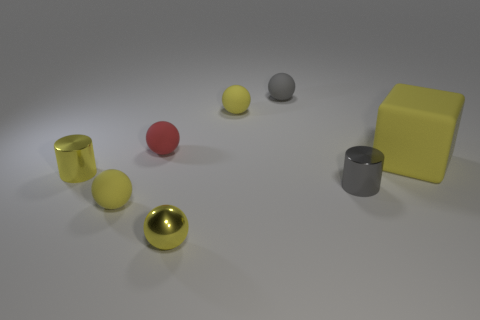How many yellow balls must be subtracted to get 1 yellow balls? 2 Subtract all yellow cubes. How many yellow spheres are left? 3 Subtract all gray balls. How many balls are left? 4 Subtract all yellow metal spheres. How many spheres are left? 4 Subtract 3 balls. How many balls are left? 2 Add 1 matte spheres. How many objects exist? 9 Subtract all green spheres. Subtract all red blocks. How many spheres are left? 5 Subtract all spheres. How many objects are left? 3 Subtract all yellow balls. Subtract all tiny metallic spheres. How many objects are left? 4 Add 8 small red balls. How many small red balls are left? 9 